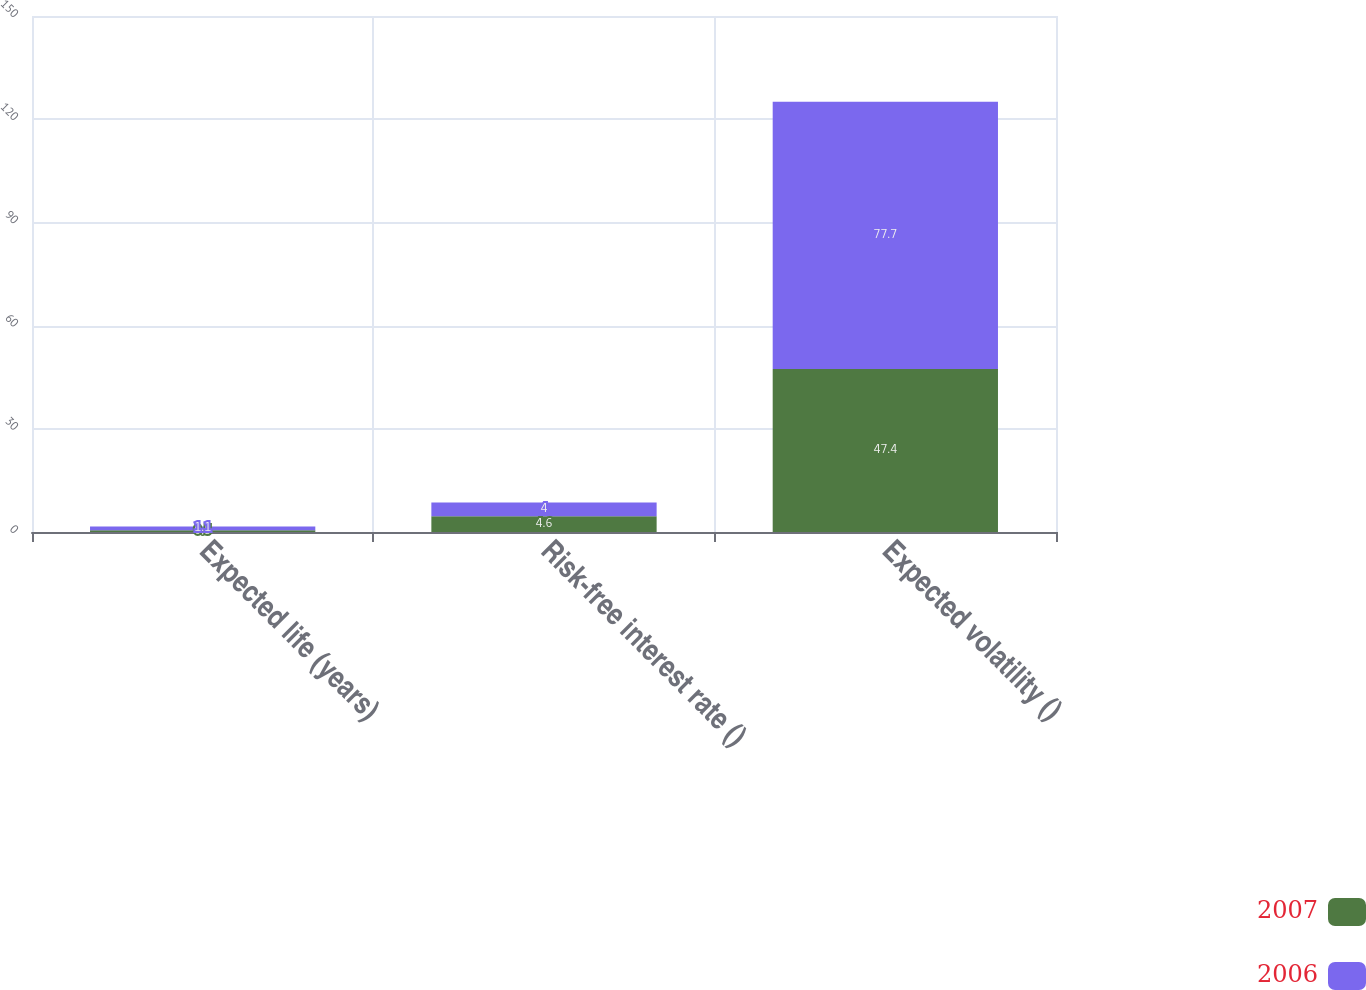<chart> <loc_0><loc_0><loc_500><loc_500><stacked_bar_chart><ecel><fcel>Expected life (years)<fcel>Risk-free interest rate ()<fcel>Expected volatility ()<nl><fcel>2007<fcel>0.5<fcel>4.6<fcel>47.4<nl><fcel>2006<fcel>1.1<fcel>4<fcel>77.7<nl></chart> 